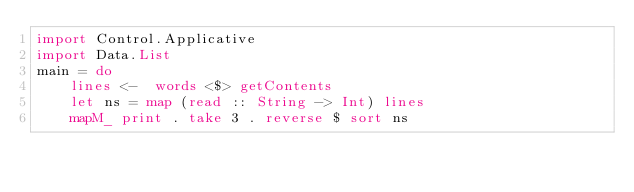Convert code to text. <code><loc_0><loc_0><loc_500><loc_500><_Haskell_>import Control.Applicative
import Data.List
main = do
    lines <-  words <$> getContents
    let ns = map (read :: String -> Int) lines
    mapM_ print . take 3 . reverse $ sort ns</code> 